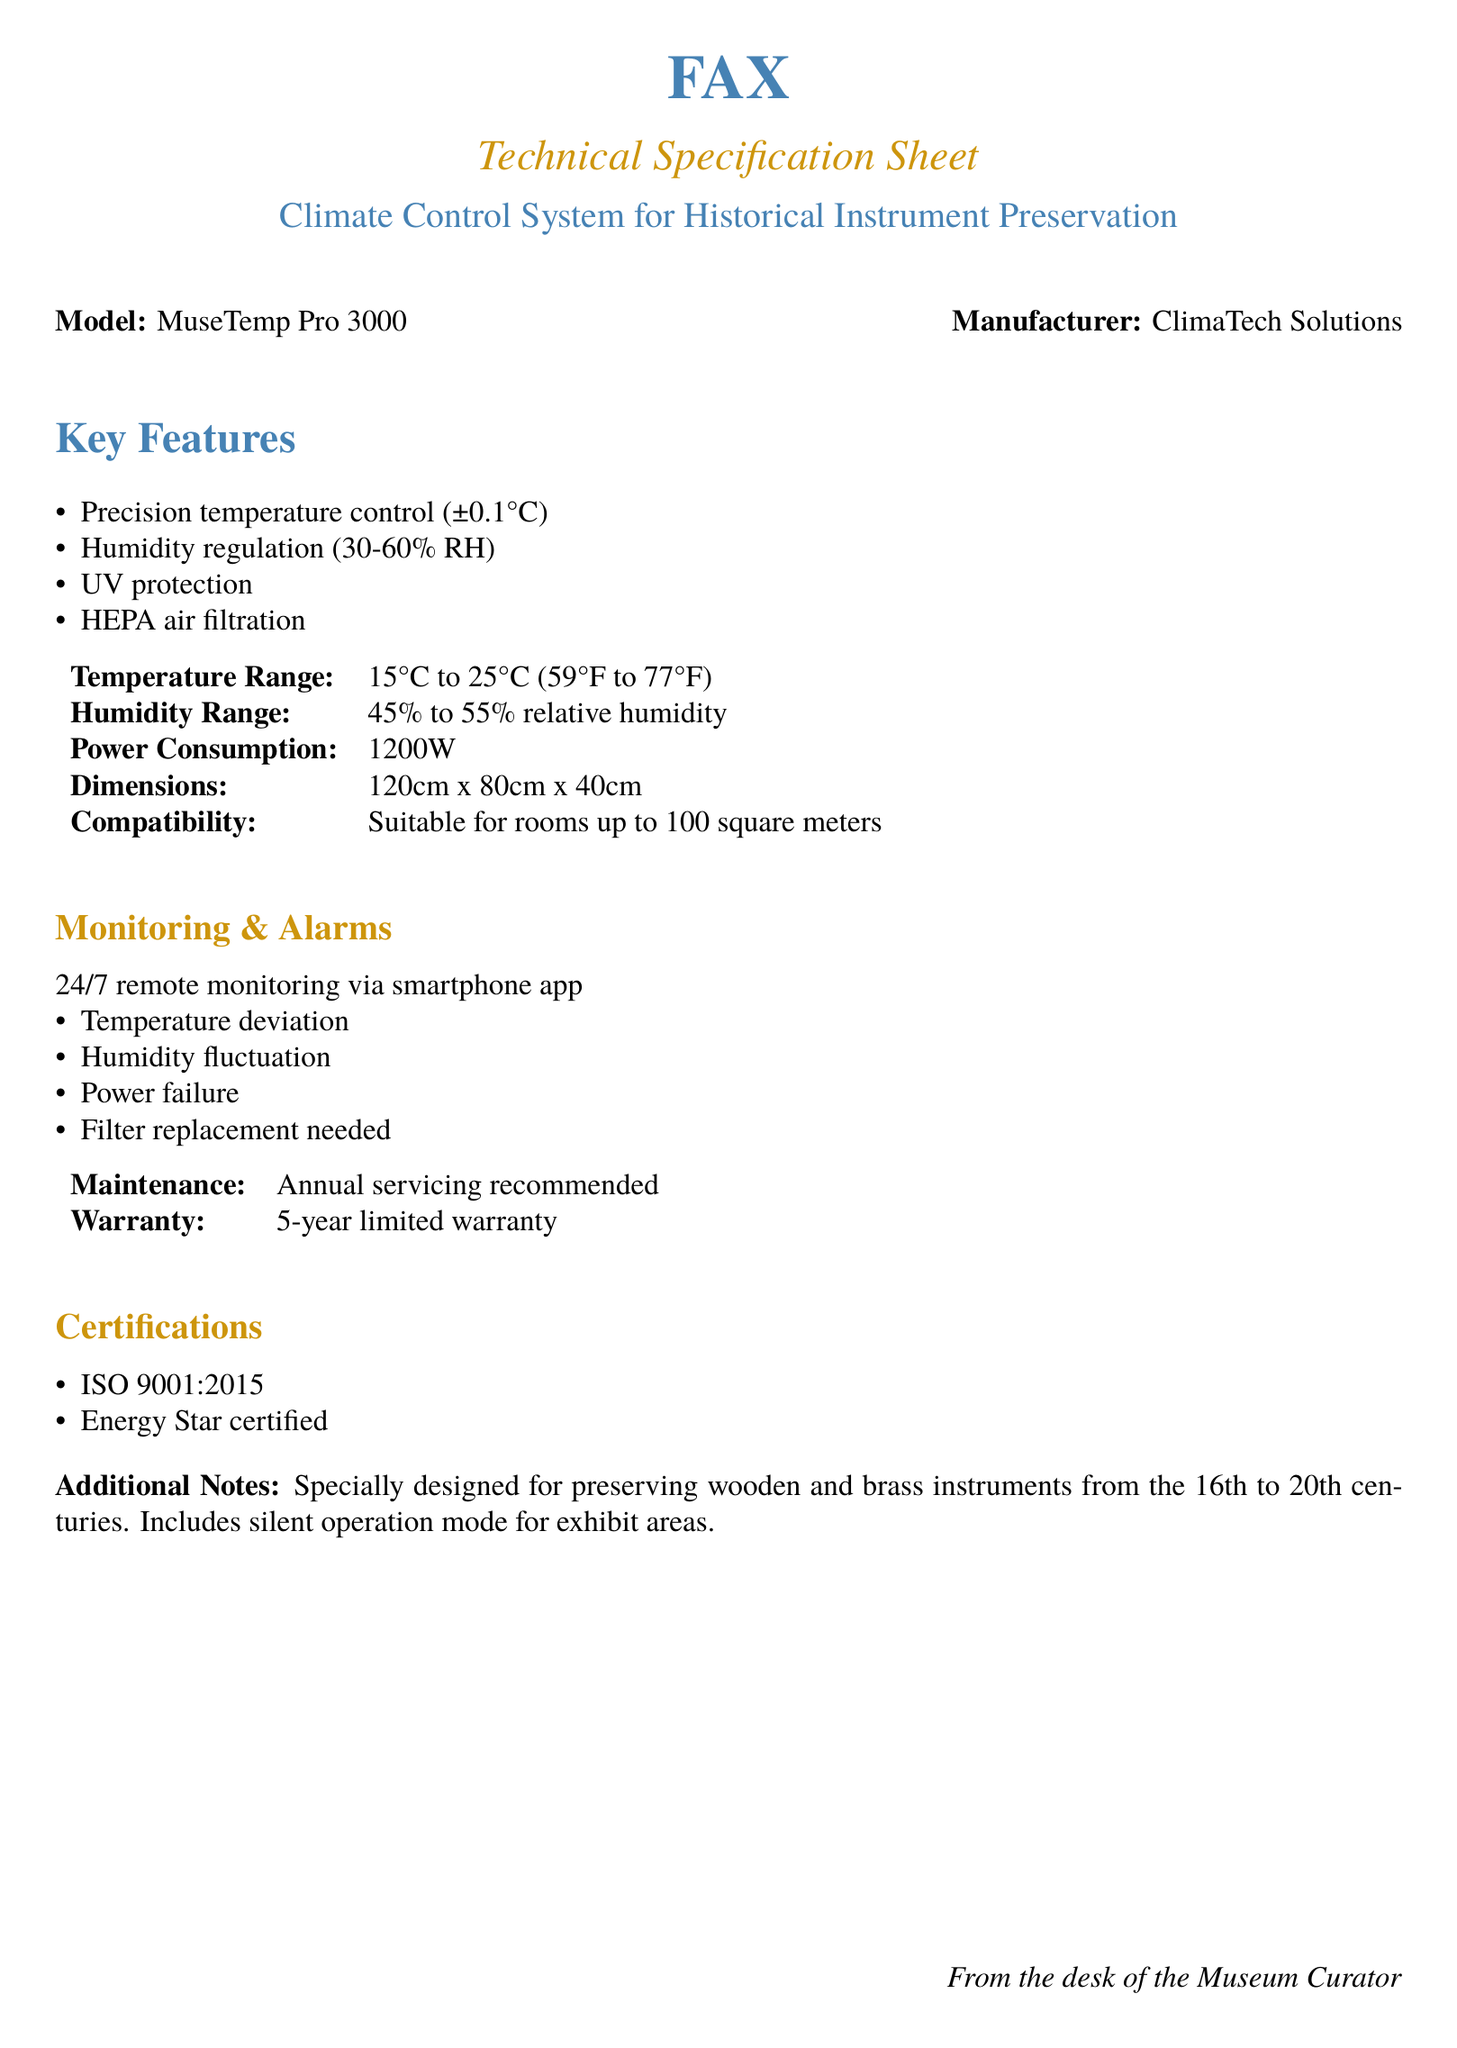What is the model of the climate control system? The model of the climate control system is provided in the document as "MuseTemp Pro 3000."
Answer: MuseTemp Pro 3000 What is the manufacturer of the climate control system? The manufacturer is mentioned in the document as "ClimaTech Solutions."
Answer: ClimaTech Solutions What is the power consumption of the system? The document specifies that the power consumption is "1200W."
Answer: 1200W What is the temperature range of the system? The temperature range is stated in the document as "15°C to 25°C (59°F to 77°F)."
Answer: 15°C to 25°C (59°F to 77°F) What is required for maintenance? The document recommends "Annual servicing."
Answer: Annual servicing What certifications does the system have? The system has certifications listed in the document, specifically "ISO 9001:2015" and "Energy Star certified."
Answer: ISO 9001:2015, Energy Star certified Why is the climate control system specially designed? The document states it is designed for "preserving wooden and brass instruments from the 16th to 20th centuries."
Answer: preserving wooden and brass instruments from the 16th to 20th centuries What feature supports silent operation? The document mentions a "silent operation mode for exhibit areas," highlighting a specific feature for quiet functioning.
Answer: silent operation mode for exhibit areas What does the system monitor continuously? The document specifies it monitors "Temperature deviation, Humidity fluctuation, Power failure, Filter replacement needed."
Answer: Temperature deviation, Humidity fluctuation, Power failure, Filter replacement needed 